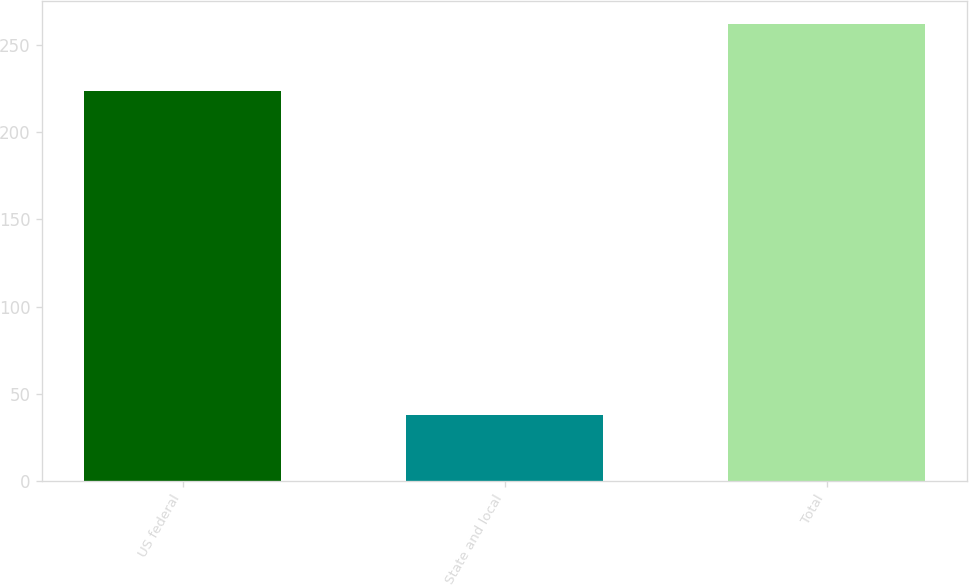Convert chart. <chart><loc_0><loc_0><loc_500><loc_500><bar_chart><fcel>US federal<fcel>State and local<fcel>Total<nl><fcel>224<fcel>38<fcel>262<nl></chart> 